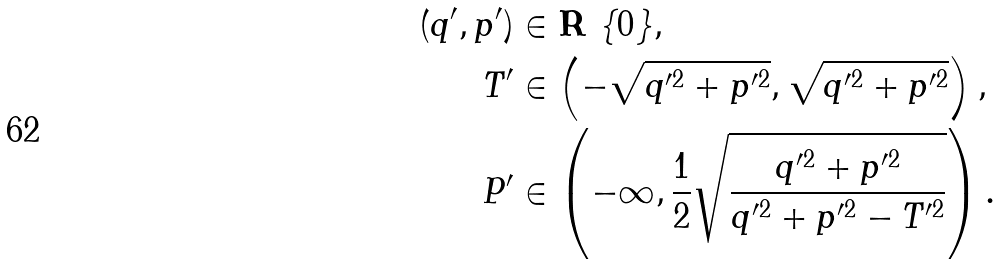Convert formula to latex. <formula><loc_0><loc_0><loc_500><loc_500>( q ^ { \prime } , p ^ { \prime } ) & \in { \mathbf R } \ \{ 0 \} , \\ T ^ { \prime } & \in \left ( - \sqrt { q ^ { \prime 2 } + p ^ { \prime 2 } } , \sqrt { q ^ { \prime 2 } + p ^ { \prime 2 } } \right ) , \\ P ^ { \prime } & \in \left ( - \infty , \frac { 1 } { 2 } \sqrt { \frac { q ^ { \prime 2 } + p ^ { \prime 2 } } { q ^ { \prime 2 } + p ^ { \prime 2 } - T ^ { \prime 2 } } } \right ) .</formula> 